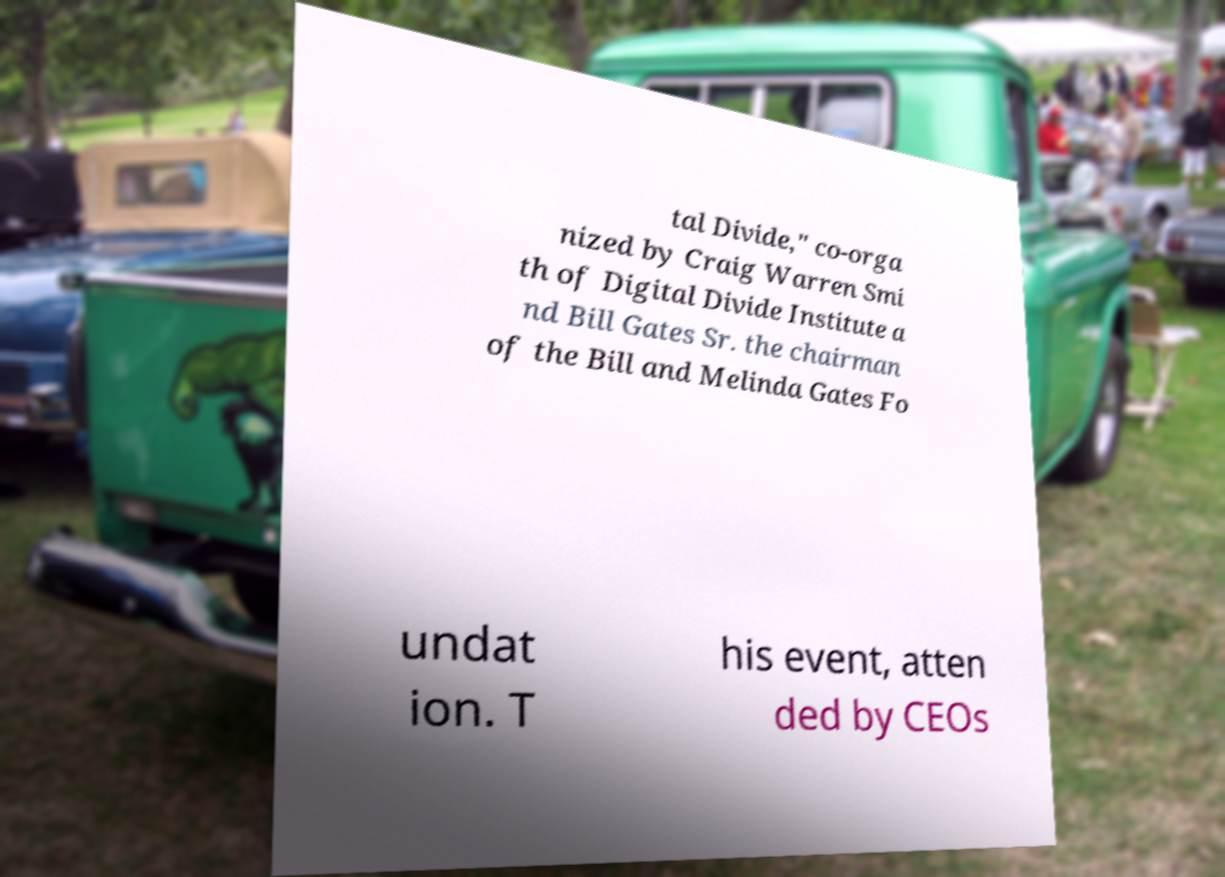Please read and relay the text visible in this image. What does it say? tal Divide," co-orga nized by Craig Warren Smi th of Digital Divide Institute a nd Bill Gates Sr. the chairman of the Bill and Melinda Gates Fo undat ion. T his event, atten ded by CEOs 